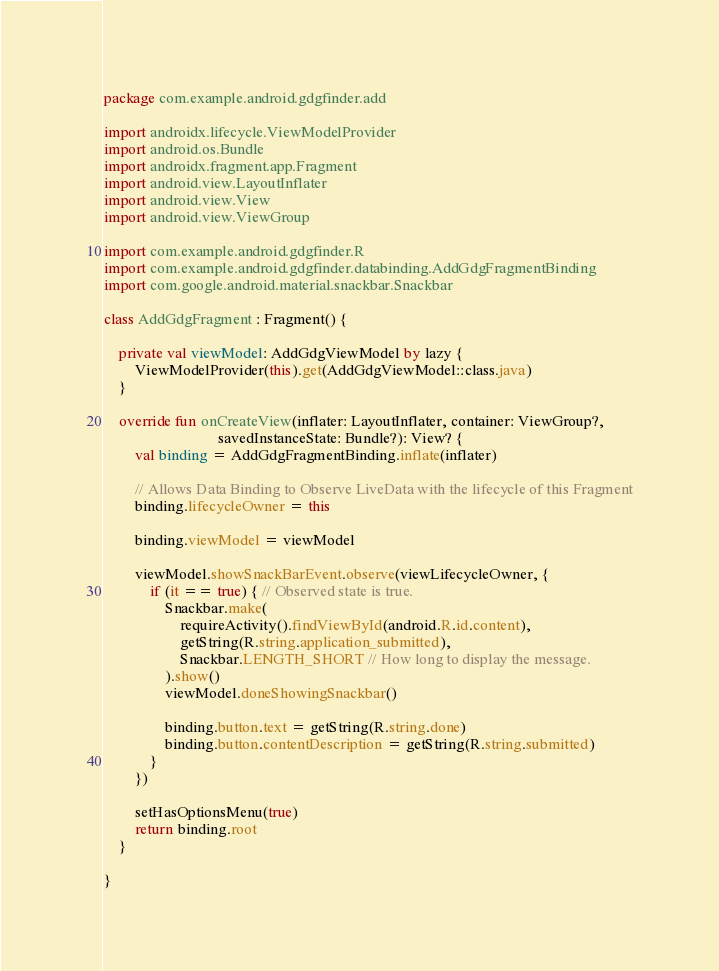Convert code to text. <code><loc_0><loc_0><loc_500><loc_500><_Kotlin_>package com.example.android.gdgfinder.add

import androidx.lifecycle.ViewModelProvider
import android.os.Bundle
import androidx.fragment.app.Fragment
import android.view.LayoutInflater
import android.view.View
import android.view.ViewGroup

import com.example.android.gdgfinder.R
import com.example.android.gdgfinder.databinding.AddGdgFragmentBinding
import com.google.android.material.snackbar.Snackbar

class AddGdgFragment : Fragment() {

    private val viewModel: AddGdgViewModel by lazy {
        ViewModelProvider(this).get(AddGdgViewModel::class.java)
    }

    override fun onCreateView(inflater: LayoutInflater, container: ViewGroup?,
                              savedInstanceState: Bundle?): View? {
        val binding = AddGdgFragmentBinding.inflate(inflater)

        // Allows Data Binding to Observe LiveData with the lifecycle of this Fragment
        binding.lifecycleOwner = this

        binding.viewModel = viewModel

        viewModel.showSnackBarEvent.observe(viewLifecycleOwner, {
            if (it == true) { // Observed state is true.
                Snackbar.make(
                    requireActivity().findViewById(android.R.id.content),
                    getString(R.string.application_submitted),
                    Snackbar.LENGTH_SHORT // How long to display the message.
                ).show()
                viewModel.doneShowingSnackbar()

                binding.button.text = getString(R.string.done)
                binding.button.contentDescription = getString(R.string.submitted)
            }
        })

        setHasOptionsMenu(true)
        return binding.root
    }

}
</code> 